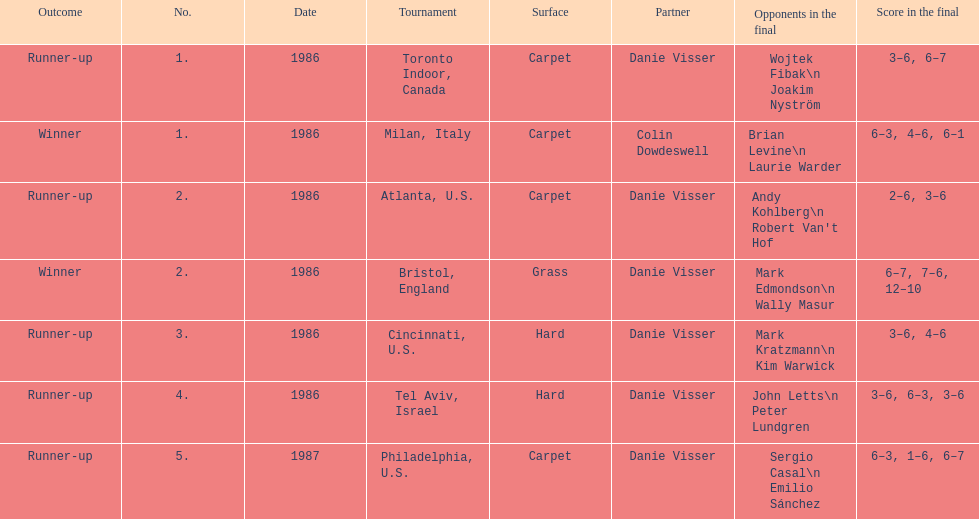Parse the full table. {'header': ['Outcome', 'No.', 'Date', 'Tournament', 'Surface', 'Partner', 'Opponents in the final', 'Score in the final'], 'rows': [['Runner-up', '1.', '1986', 'Toronto Indoor, Canada', 'Carpet', 'Danie Visser', 'Wojtek Fibak\\n Joakim Nyström', '3–6, 6–7'], ['Winner', '1.', '1986', 'Milan, Italy', 'Carpet', 'Colin Dowdeswell', 'Brian Levine\\n Laurie Warder', '6–3, 4–6, 6–1'], ['Runner-up', '2.', '1986', 'Atlanta, U.S.', 'Carpet', 'Danie Visser', "Andy Kohlberg\\n Robert Van't Hof", '2–6, 3–6'], ['Winner', '2.', '1986', 'Bristol, England', 'Grass', 'Danie Visser', 'Mark Edmondson\\n Wally Masur', '6–7, 7–6, 12–10'], ['Runner-up', '3.', '1986', 'Cincinnati, U.S.', 'Hard', 'Danie Visser', 'Mark Kratzmann\\n Kim Warwick', '3–6, 4–6'], ['Runner-up', '4.', '1986', 'Tel Aviv, Israel', 'Hard', 'Danie Visser', 'John Letts\\n Peter Lundgren', '3–6, 6–3, 3–6'], ['Runner-up', '5.', '1987', 'Philadelphia, U.S.', 'Carpet', 'Danie Visser', 'Sergio Casal\\n Emilio Sánchez', '6–3, 1–6, 6–7']]} What is the overall total of grass and hard surfaces indicated? 3. 